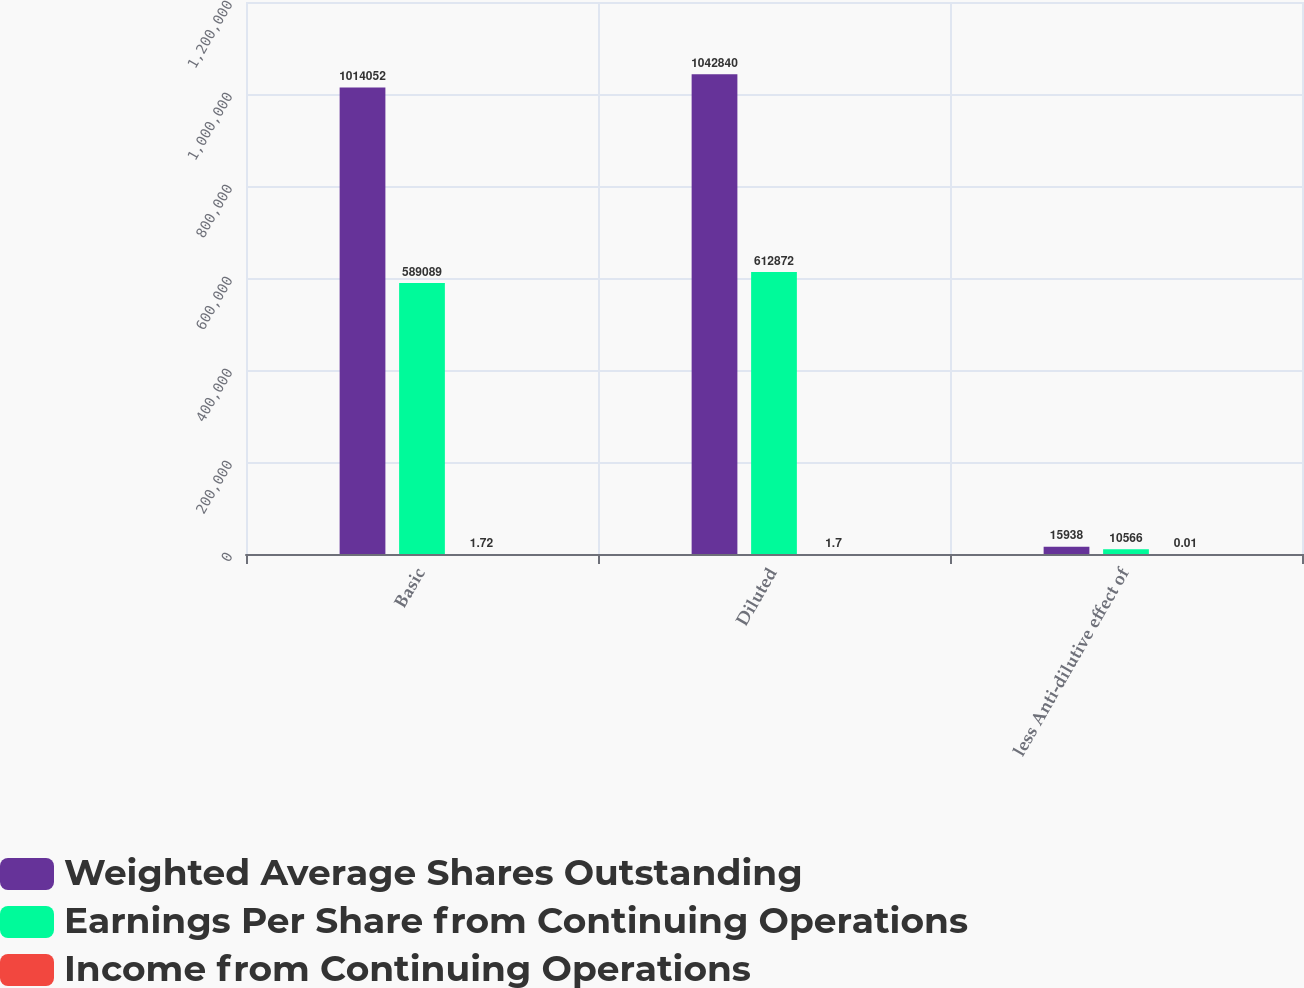Convert chart. <chart><loc_0><loc_0><loc_500><loc_500><stacked_bar_chart><ecel><fcel>Basic<fcel>Diluted<fcel>less Anti-dilutive effect of<nl><fcel>Weighted Average Shares Outstanding<fcel>1.01405e+06<fcel>1.04284e+06<fcel>15938<nl><fcel>Earnings Per Share from Continuing Operations<fcel>589089<fcel>612872<fcel>10566<nl><fcel>Income from Continuing Operations<fcel>1.72<fcel>1.7<fcel>0.01<nl></chart> 